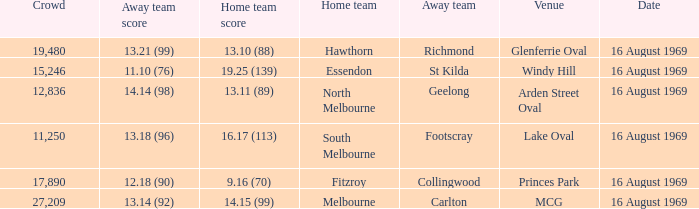Would you mind parsing the complete table? {'header': ['Crowd', 'Away team score', 'Home team score', 'Home team', 'Away team', 'Venue', 'Date'], 'rows': [['19,480', '13.21 (99)', '13.10 (88)', 'Hawthorn', 'Richmond', 'Glenferrie Oval', '16 August 1969'], ['15,246', '11.10 (76)', '19.25 (139)', 'Essendon', 'St Kilda', 'Windy Hill', '16 August 1969'], ['12,836', '14.14 (98)', '13.11 (89)', 'North Melbourne', 'Geelong', 'Arden Street Oval', '16 August 1969'], ['11,250', '13.18 (96)', '16.17 (113)', 'South Melbourne', 'Footscray', 'Lake Oval', '16 August 1969'], ['17,890', '12.18 (90)', '9.16 (70)', 'Fitzroy', 'Collingwood', 'Princes Park', '16 August 1969'], ['27,209', '13.14 (92)', '14.15 (99)', 'Melbourne', 'Carlton', 'MCG', '16 August 1969']]} What was the away team when the game was at Princes Park? Collingwood. 